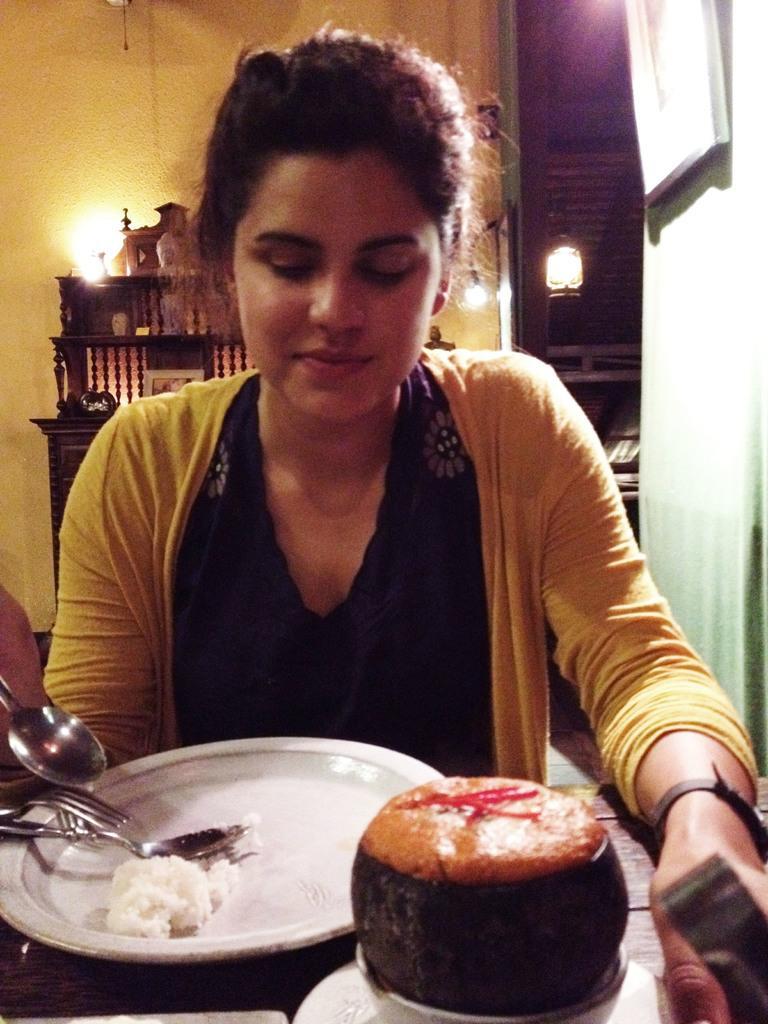How would you summarize this image in a sentence or two? In this image we can see a woman. And we can see some food items on the plate which is on a wooden surface. And we can see the spoons and fork. And we can see the wall and some wooden objects. And we can see the lights. 